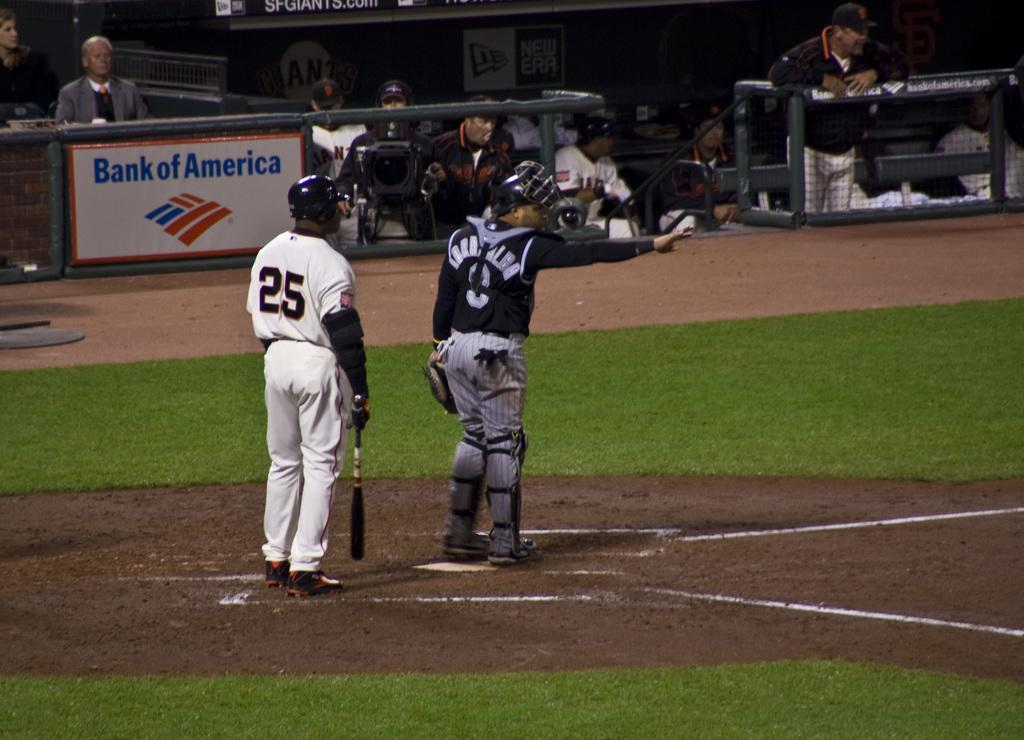<image>
Provide a brief description of the given image. Baseball catcher and batter standing at plate sponsored by Bank of America. 